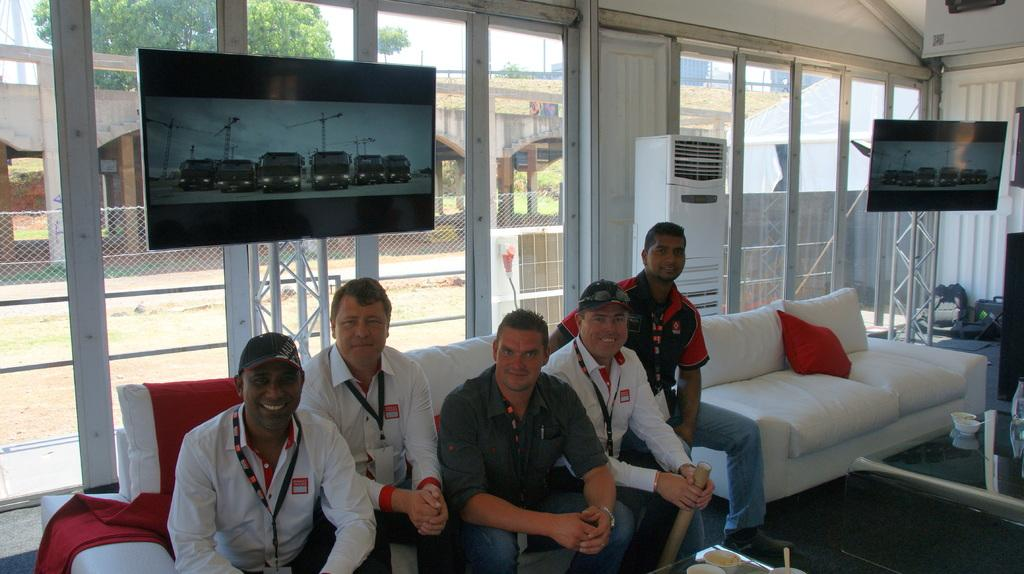What are the people in the image doing? The people in the image are sitting on a sofa. What can be seen in the background of the image? There are screens visible in the background. Can you describe the sofa in the image? There is a sofa with a cushion in the image. What type of spoon is being used to touch the floor in the image? There is no spoon or touching of the floor present in the image. 